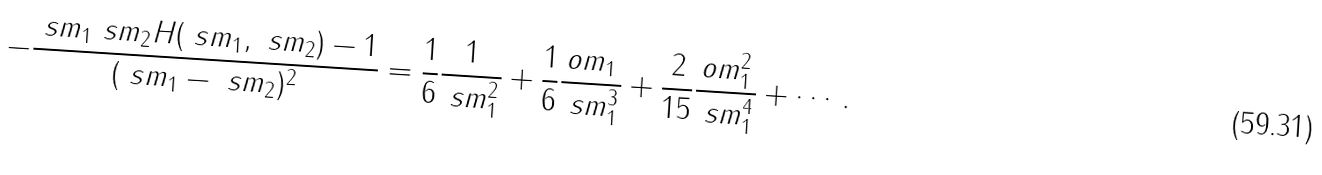Convert formula to latex. <formula><loc_0><loc_0><loc_500><loc_500>- \frac { \ s m _ { 1 } \ s m _ { 2 } H ( \ s m _ { 1 } , \ s m _ { 2 } ) - 1 } { ( \ s m _ { 1 } - \ s m _ { 2 } ) ^ { 2 } } = \frac { 1 } { 6 } \frac { 1 } { \ s m _ { 1 } ^ { 2 } } + \frac { 1 } { 6 } \frac { o m _ { 1 } } { \ s m _ { 1 } ^ { 3 } } + \frac { 2 } { 1 5 } \frac { o m _ { 1 } ^ { 2 } } { \ s m _ { 1 } ^ { 4 } } + \cdots \, .</formula> 